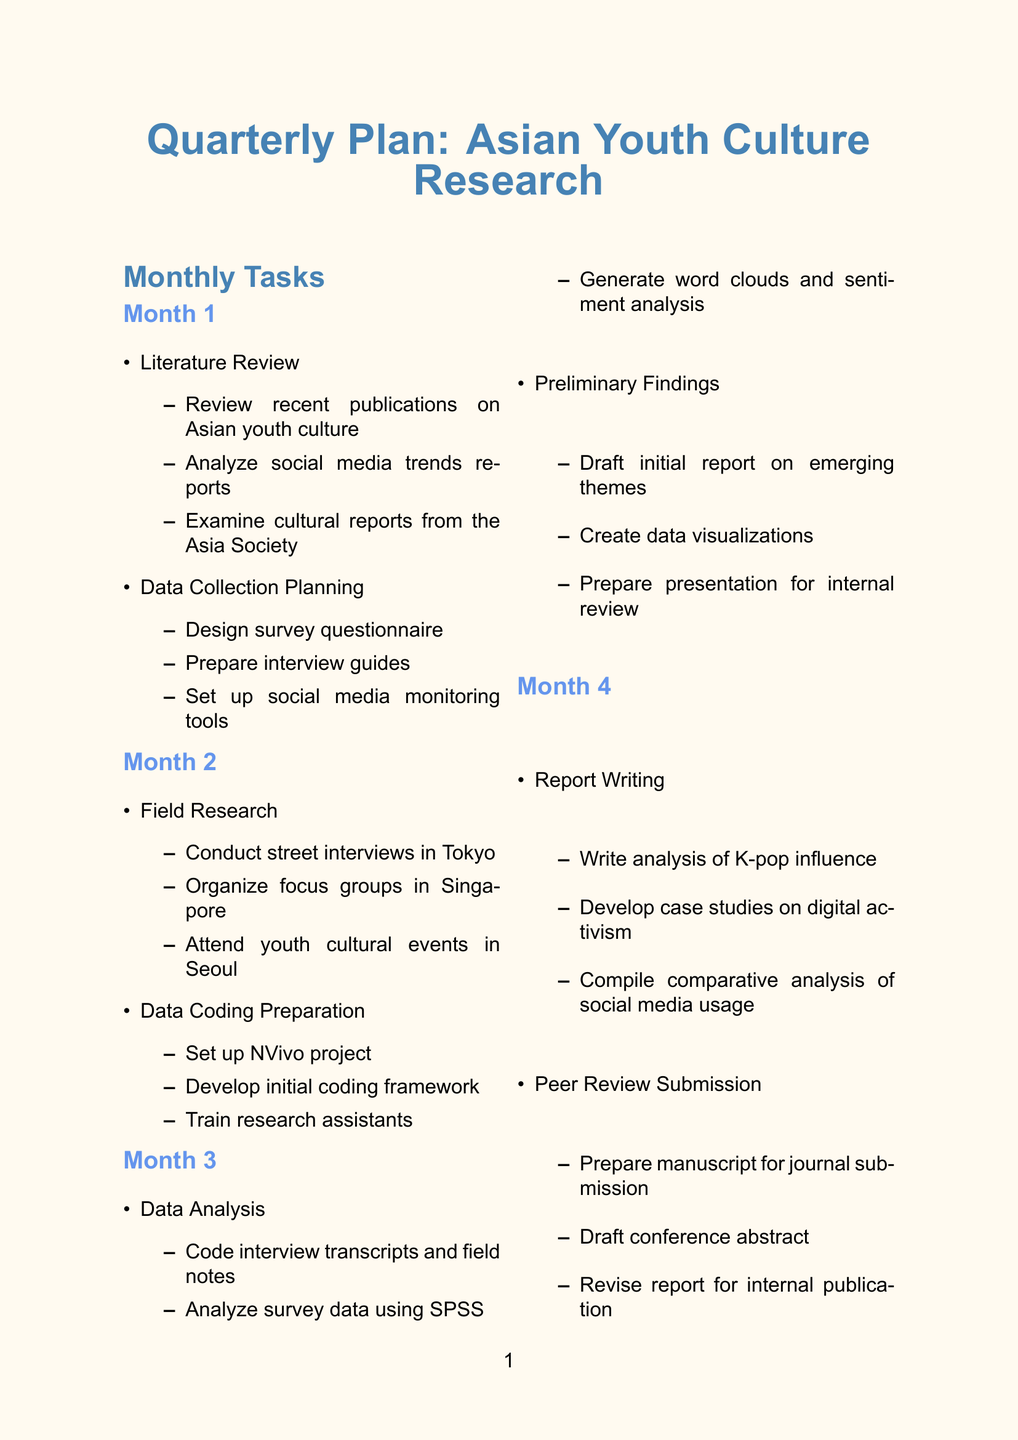What is the first task in Month 1? The first task listed in Month 1 is "Literature Review."
Answer: Literature Review What is the deadline for the Data Collection Completion milestone? The deadline for the Data Collection Completion is specified as "Mid-Month 2."
Answer: Mid-Month 2 Which software tool is used for qualitative data analysis? The software tool designated for qualitative data analysis in the document is NVivo.
Answer: NVivo What is the name of the journal for the peer review submission? The document states that the manuscript is to be submitted to the "Asian Journal of Social Science."
Answer: Asian Journal of Social Science How many tasks are in Month 3? Month 3 has two main tasks listed in the document.
Answer: 2 What type of analysis will be generated from social media data? The analysis type that will be generated from social media data is "word clouds and sentiment analysis."
Answer: Word clouds and sentiment analysis What are the focus group locations mentioned for Month 2? The focus groups are organized with university students in Singapore, as mentioned in the document.
Answer: Singapore When is the final report draft deadline? The deadline for the final report draft is stated as "Mid-Month 4."
Answer: Mid-Month 4 